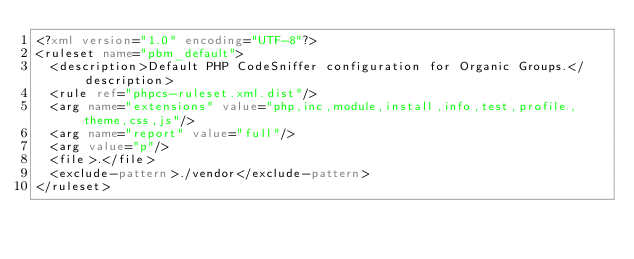Convert code to text. <code><loc_0><loc_0><loc_500><loc_500><_XML_><?xml version="1.0" encoding="UTF-8"?>
<ruleset name="pbm_default">
  <description>Default PHP CodeSniffer configuration for Organic Groups.</description>
  <rule ref="phpcs-ruleset.xml.dist"/>
  <arg name="extensions" value="php,inc,module,install,info,test,profile,theme,css,js"/>
  <arg name="report" value="full"/>
  <arg value="p"/>
  <file>.</file>
  <exclude-pattern>./vendor</exclude-pattern>
</ruleset>
</code> 